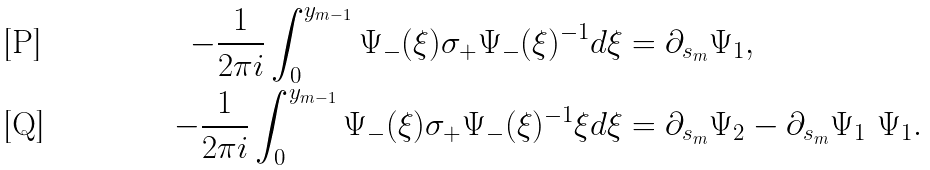<formula> <loc_0><loc_0><loc_500><loc_500>- \frac { 1 } { 2 \pi i } \int _ { 0 } ^ { y _ { m - 1 } } \Psi _ { - } ( \xi ) \sigma _ { + } \Psi _ { - } ( \xi ) ^ { - 1 } d \xi & = \partial _ { s _ { m } } \Psi _ { 1 } , \\ - \frac { 1 } { 2 \pi i } \int _ { 0 } ^ { y _ { m - 1 } } \Psi _ { - } ( \xi ) \sigma _ { + } \Psi _ { - } ( \xi ) ^ { - 1 } \xi d \xi & = \partial _ { s _ { m } } \Psi _ { 2 } - \partial _ { s _ { m } } \Psi _ { 1 } \ \Psi _ { 1 } .</formula> 